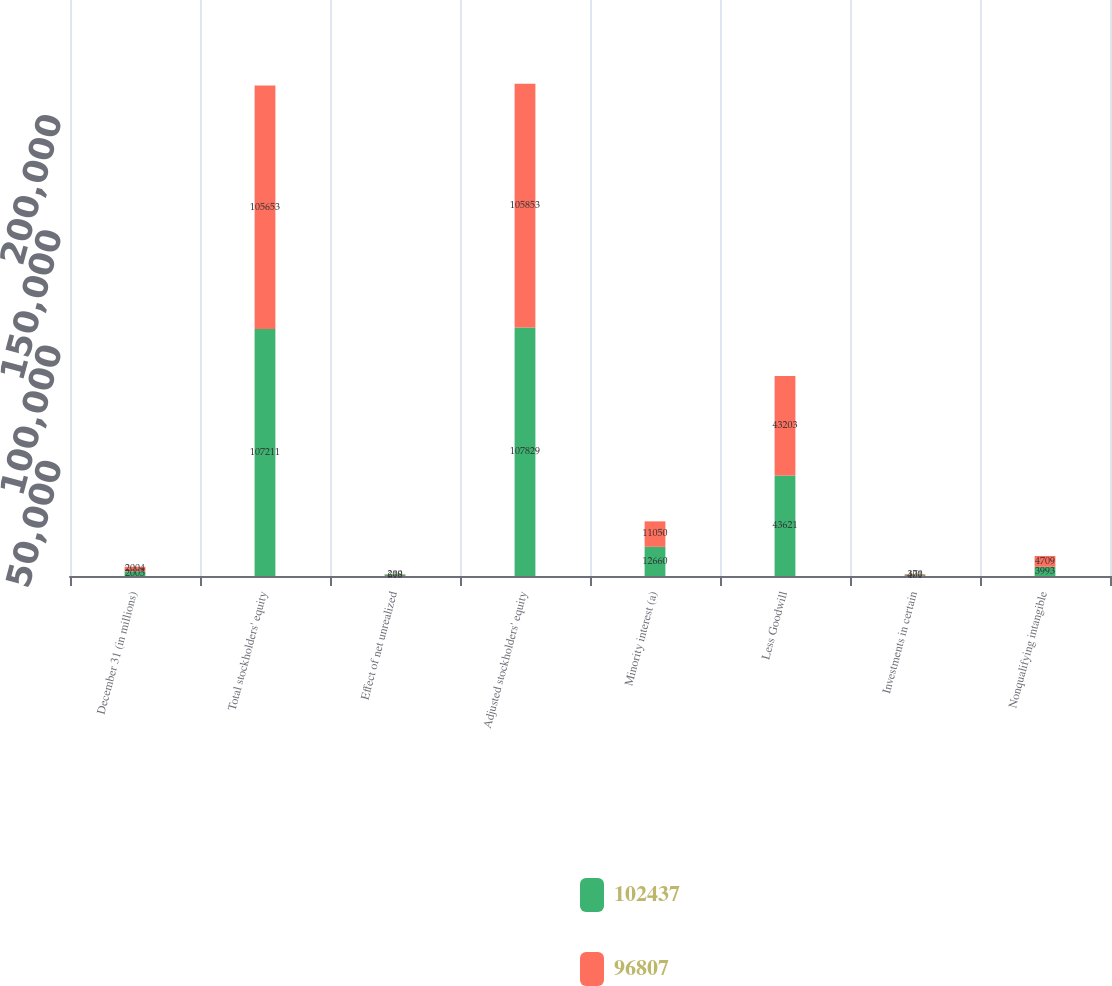Convert chart to OTSL. <chart><loc_0><loc_0><loc_500><loc_500><stacked_bar_chart><ecel><fcel>December 31 (in millions)<fcel>Total stockholders' equity<fcel>Effect of net unrealized<fcel>Adjusted stockholders' equity<fcel>Minority interest (a)<fcel>Less Goodwill<fcel>Investments in certain<fcel>Nonqualifying intangible<nl><fcel>102437<fcel>2005<fcel>107211<fcel>618<fcel>107829<fcel>12660<fcel>43621<fcel>401<fcel>3993<nl><fcel>96807<fcel>2004<fcel>105653<fcel>200<fcel>105853<fcel>11050<fcel>43203<fcel>370<fcel>4709<nl></chart> 